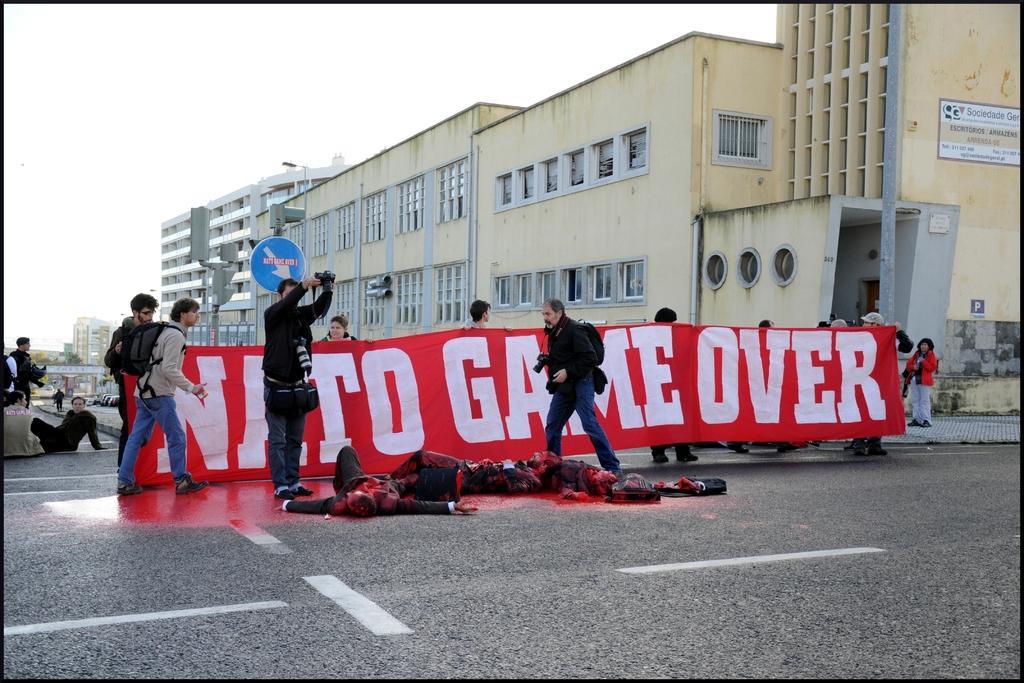Could you give a brief overview of what you see in this image? In this image we can see some people and among them few people are lying on the road and there are two persons holding cameras. There is a banner with some text and we can see a sign board and in the background, we can see some buildings and at the top we can see the sky. 